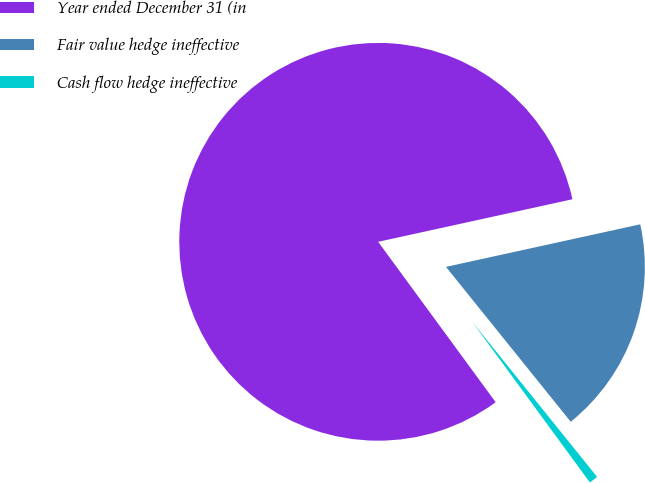<chart> <loc_0><loc_0><loc_500><loc_500><pie_chart><fcel>Year ended December 31 (in<fcel>Fair value hedge ineffective<fcel>Cash flow hedge ineffective<nl><fcel>81.63%<fcel>17.64%<fcel>0.73%<nl></chart> 